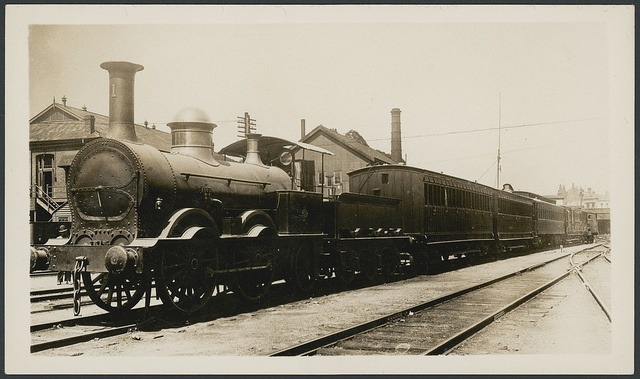Describe the objects in this image and their specific colors. I can see train in black and gray tones and people in black, gray, and darkgray tones in this image. 